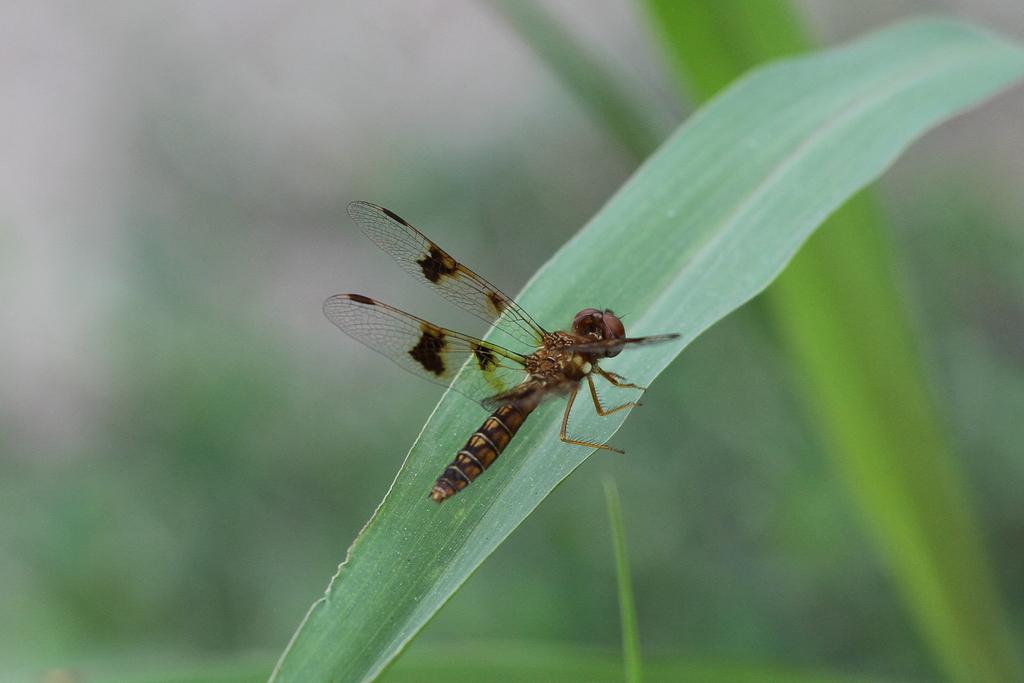What is present on the leaf in the image? There is a fly on a leaf in the image. What is the main subject of the image? The main subject of the image is the fly on the leaf. What is the background of the image made to look like? The background of the image gives an illusion of leaves. Can you see any rats hiding among the plants in the image? There are no rats or plants present in the image; it only features a fly on a leaf and an illusion of leaves in the background. 